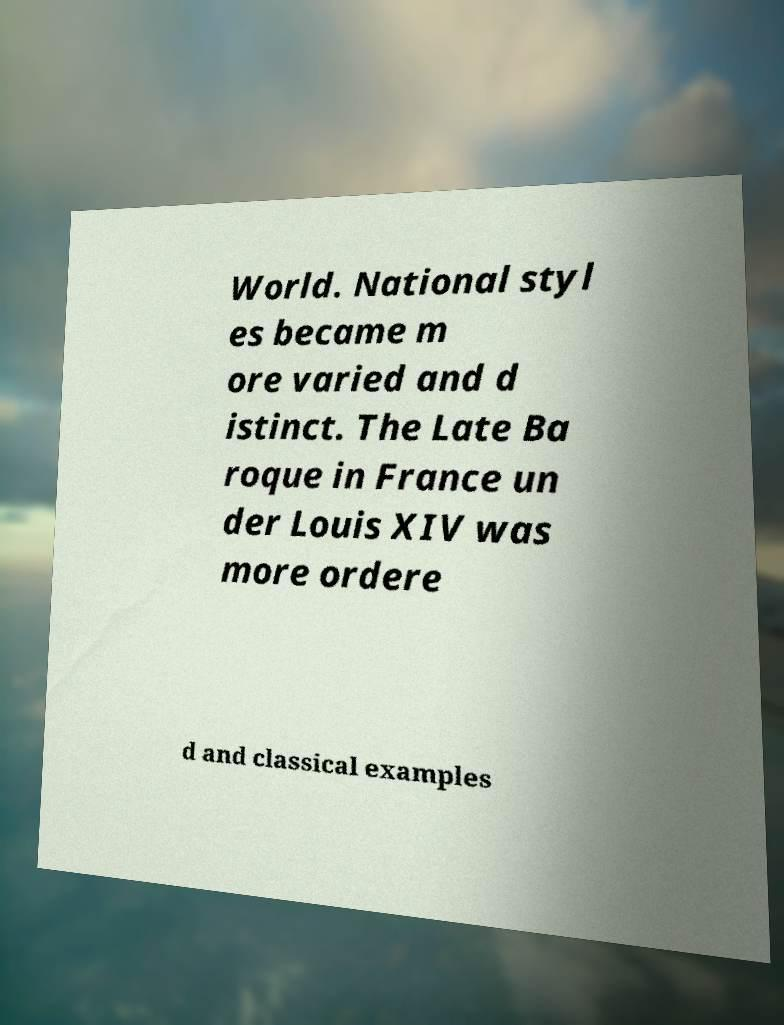Please read and relay the text visible in this image. What does it say? World. National styl es became m ore varied and d istinct. The Late Ba roque in France un der Louis XIV was more ordere d and classical examples 